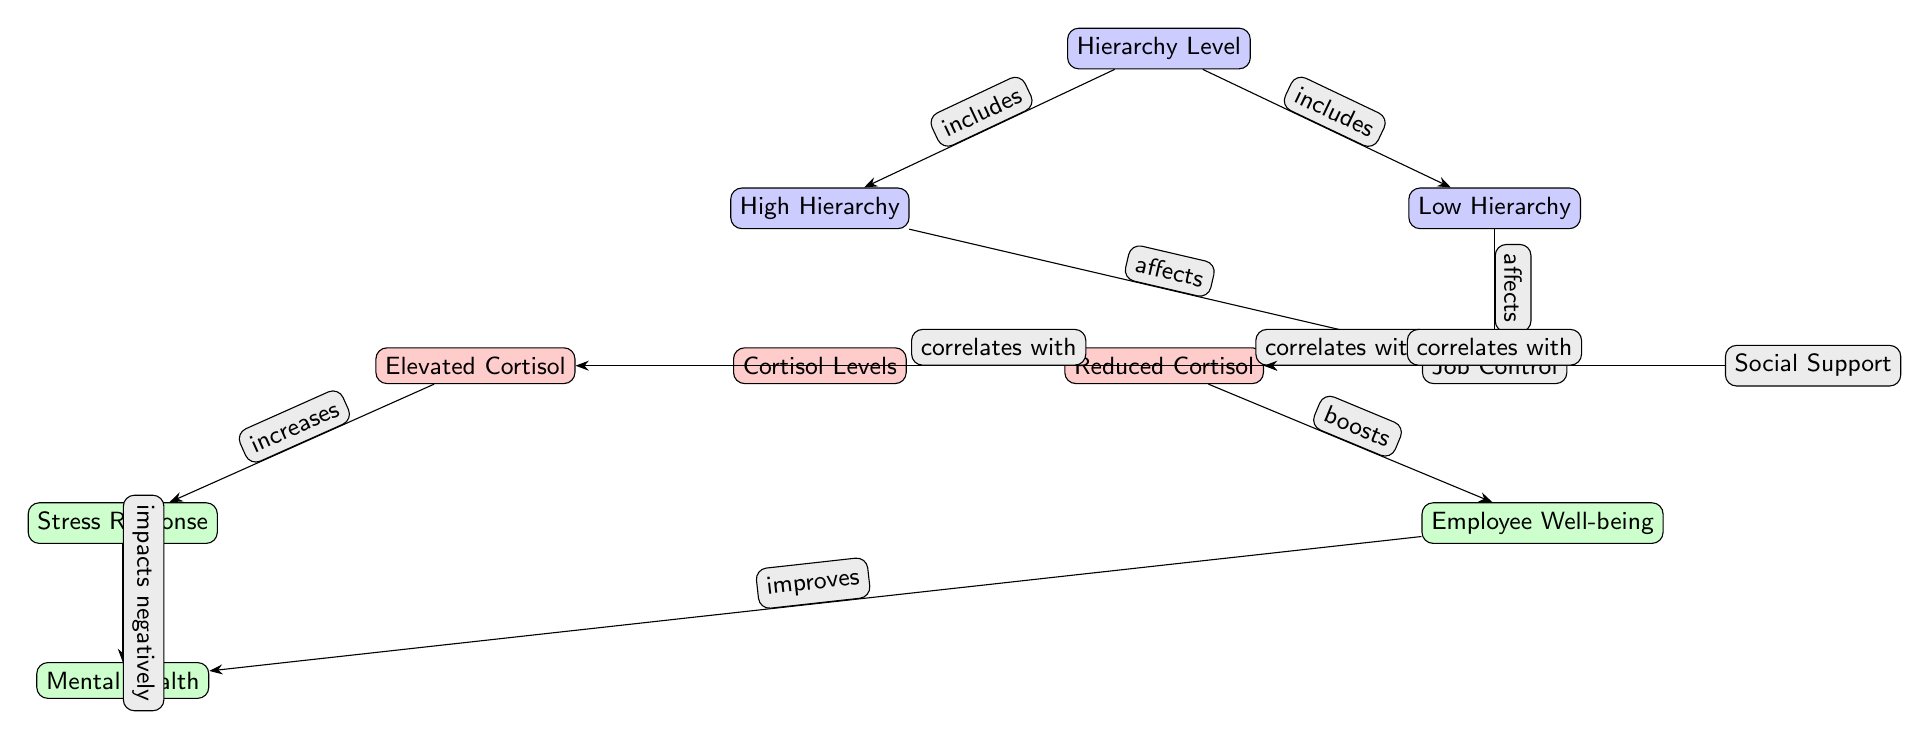What are the two types of hierarchy levels in the diagram? The diagram shows two hierarchy levels: High Hierarchy and Low Hierarchy. These are labeled directly within the "Hierarchy Level" node.
Answer: High Hierarchy, Low Hierarchy What is the correlation between job control and cortisol levels in high hierarchy? According to the diagram, in High Hierarchy, increased Job Control is correlated with Elevated Cortisol levels. This relationship is indicated by the directed edge from Job Control to Elevated Cortisol.
Answer: Elevated Cortisol How many total nodes are present in the diagram? Upon counting all individual nodes (including hierarchy levels, cortisol levels, job control, social support, employee responses, and mental health), there are a total of 9 nodes present.
Answer: 9 What effect does reduced cortisol have on employee well-being? The diagram indicates that Reduced Cortisol boosts Employee Well-being, with a directed edge from Reduced Cortisol to Employee Well-being.
Answer: Boosts What is the relationship between stress response and mental health? The diagram illustrates that Stress Response impacts Mental Health negatively, as shown by the directed edge flowing from Stress Response to Mental Health.
Answer: Impacts negatively What is the impact of elevated cortisol on stress response? Elevated Cortisol increases the Stress Response, as indicated by the directed edge leading from Elevated Cortisol to Stress Response in the diagram.
Answer: Increases Which node represents social support, and how is it related to the overall diagram? The node labeled "Social Support" is located to the right of Job Control, and it correlates with Reduced Cortisol levels, suggesting its role in moderating cortisol responses within organizational hierarchies.
Answer: Social Support How is job control affected by the hierarchy levels? Both high and low hierarchy levels affect Job Control, as represented by directed edges from both "High Hierarchy" and "Low Hierarchy" nodes pointing towards the "Job Control" node.
Answer: Affected by both Explain the overall effect of high organizational hierarchy on employee mental health. High organizational hierarchy leads to elevated cortisol levels due to job control issues, which increases stress responses that negatively impact mental health. Therefore, it's a cascading effect throughout the nodes.
Answer: Negatively impacts mental health 